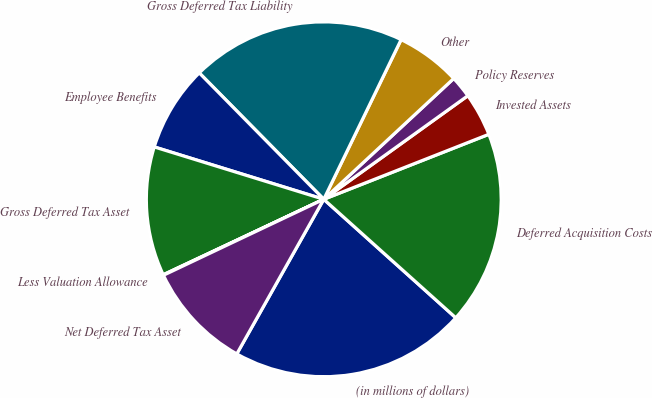Convert chart. <chart><loc_0><loc_0><loc_500><loc_500><pie_chart><fcel>(in millions of dollars)<fcel>Deferred Acquisition Costs<fcel>Invested Assets<fcel>Policy Reserves<fcel>Other<fcel>Gross Deferred Tax Liability<fcel>Employee Benefits<fcel>Gross Deferred Tax Asset<fcel>Less Valuation Allowance<fcel>Net Deferred Tax Asset<nl><fcel>21.51%<fcel>17.61%<fcel>3.95%<fcel>2.0%<fcel>5.9%<fcel>19.56%<fcel>7.85%<fcel>11.76%<fcel>0.05%<fcel>9.8%<nl></chart> 